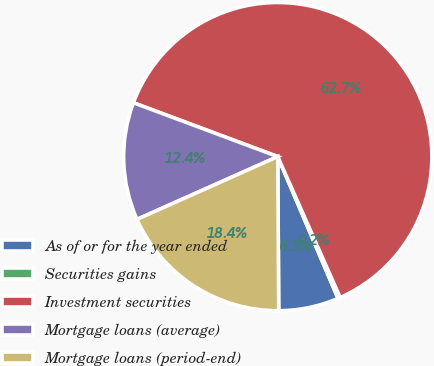Convert chart. <chart><loc_0><loc_0><loc_500><loc_500><pie_chart><fcel>As of or for the year ended<fcel>Securities gains<fcel>Investment securities<fcel>Mortgage loans (average)<fcel>Mortgage loans (period-end)<nl><fcel>6.3%<fcel>0.24%<fcel>62.68%<fcel>12.36%<fcel>18.42%<nl></chart> 